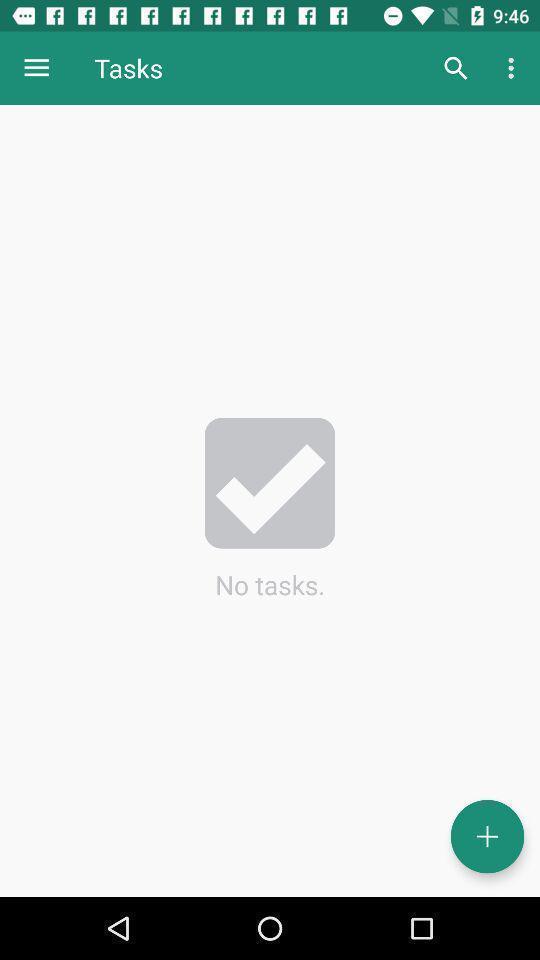Provide a description of this screenshot. Tasks status showing in android application. 